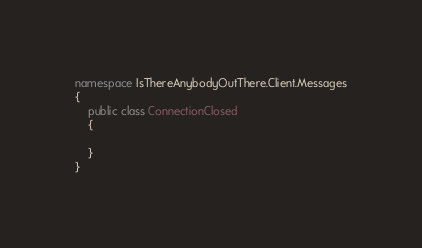Convert code to text. <code><loc_0><loc_0><loc_500><loc_500><_C#_>namespace IsThereAnybodyOutThere.Client.Messages
{
    public class ConnectionClosed
    {

    }
}</code> 